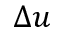Convert formula to latex. <formula><loc_0><loc_0><loc_500><loc_500>\Delta u</formula> 